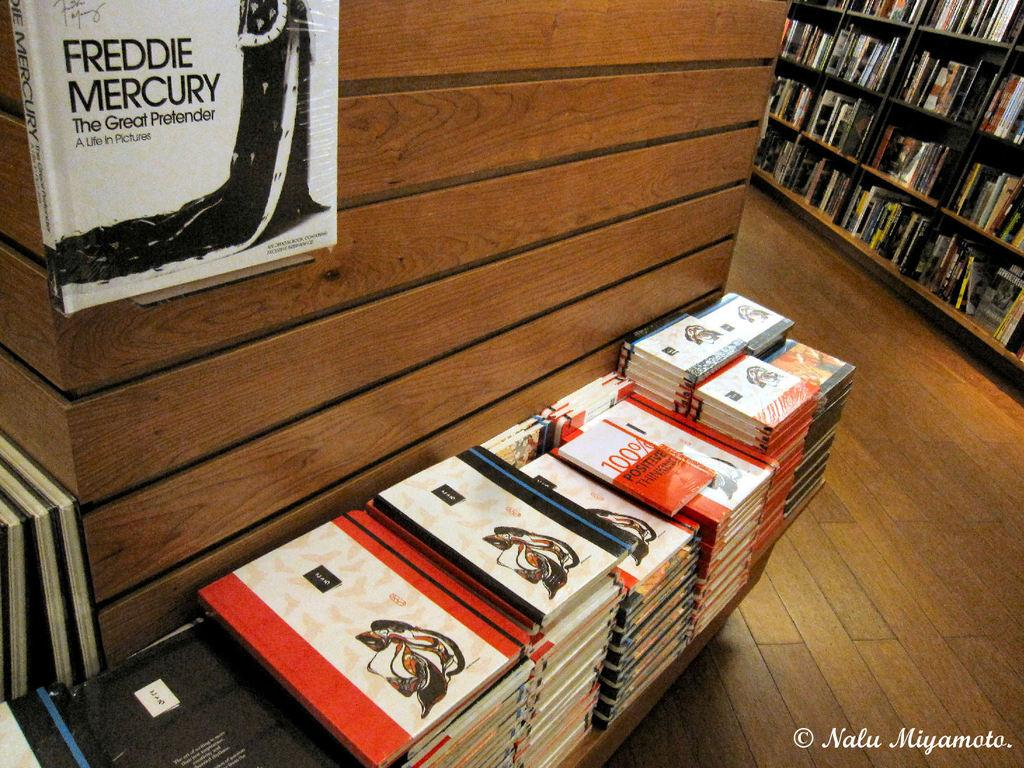<image>
Present a compact description of the photo's key features. Stack of books in a book store including one that says "Freddie Mercury" hanging on top. 